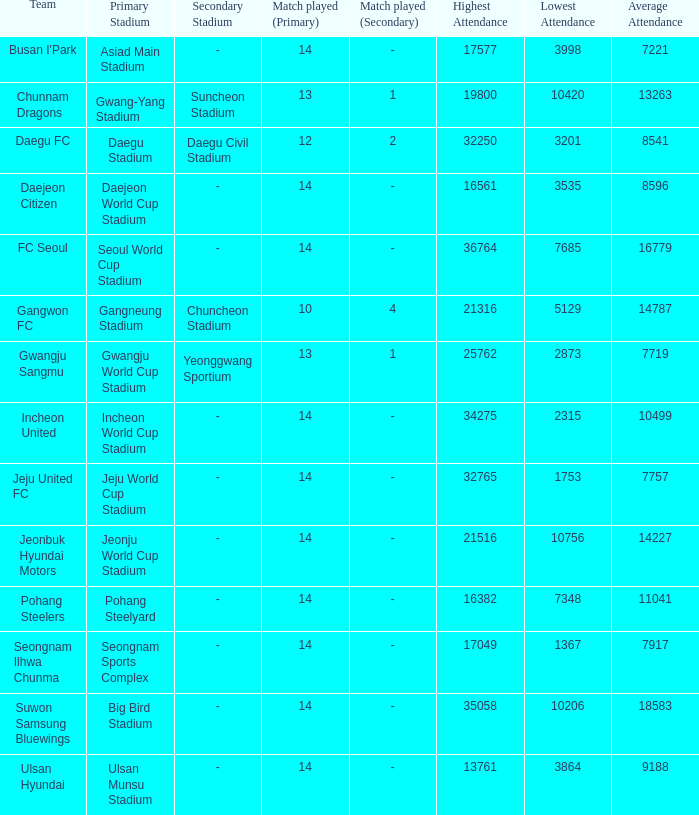How many match played have the highest as 32250? 12 2. 